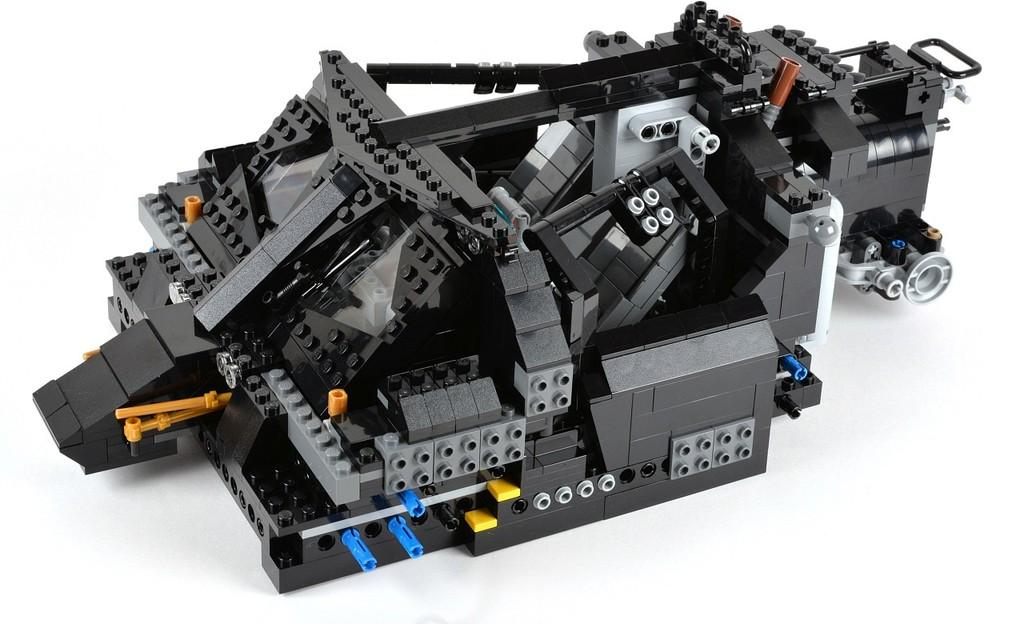What is the main subject of the image? The main subject of the image is a lego. What colors can be seen on the lego? The lego has black, grey, blue, and yellow colors. What is the color of the surface on which the lego is placed? The lego is on a white surface. What type of attraction can be seen in the background of the image? There is no background or attraction present in the image; it only features a lego on a white surface. What tool is being used to rake the lego in the image? There is no tool or raking action present in the image; it only features a lego on a white surface. 